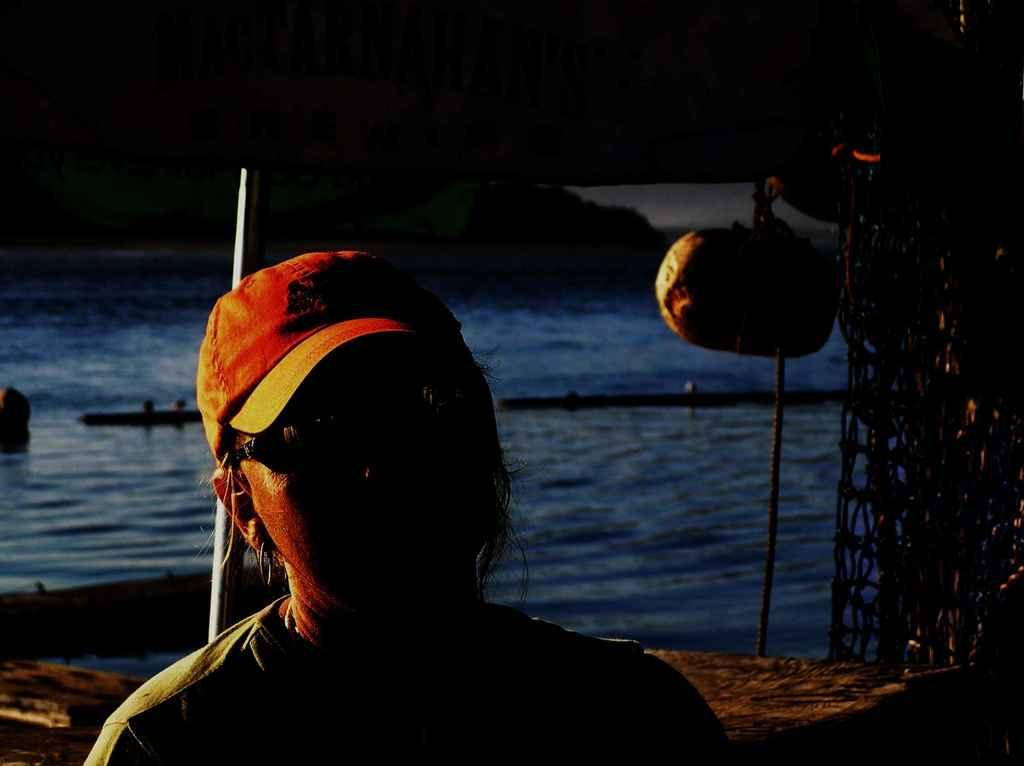Who is present in the image? There is a woman in the image. What is the woman wearing on her head? The woman is wearing a cap. What is the woman wearing to protect her eyes? The woman is wearing goggles. What can be seen in the background of the image? There is a net, a pole, water, a container, and the sky visible in the background of the image. What type of bike is the woman riding in the image? There is no bike present in the image. How is the woman sorting the items in the container in the image? There is no sorting activity depicted in the image; the woman is not interacting with the container. 